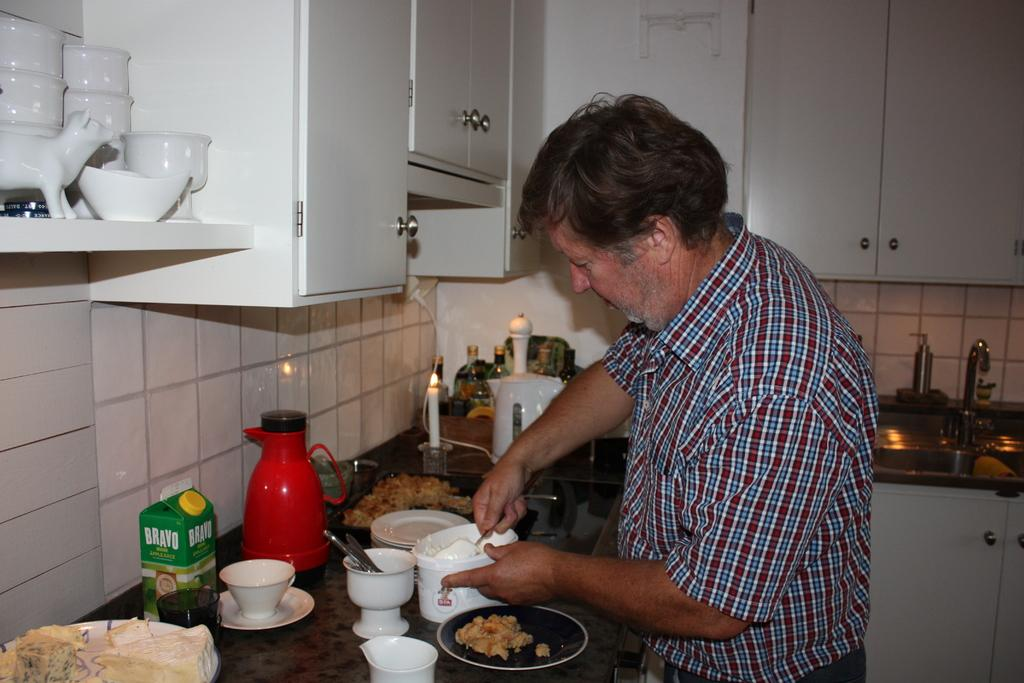<image>
Relay a brief, clear account of the picture shown. A man is cooking and a carton of "BRAVO Apple Juice" is on the counter. 